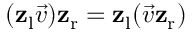Convert formula to latex. <formula><loc_0><loc_0><loc_500><loc_500>( z _ { l } { \vec { v } } ) z _ { r } = z _ { l } ( { \vec { v } } z _ { r } )</formula> 